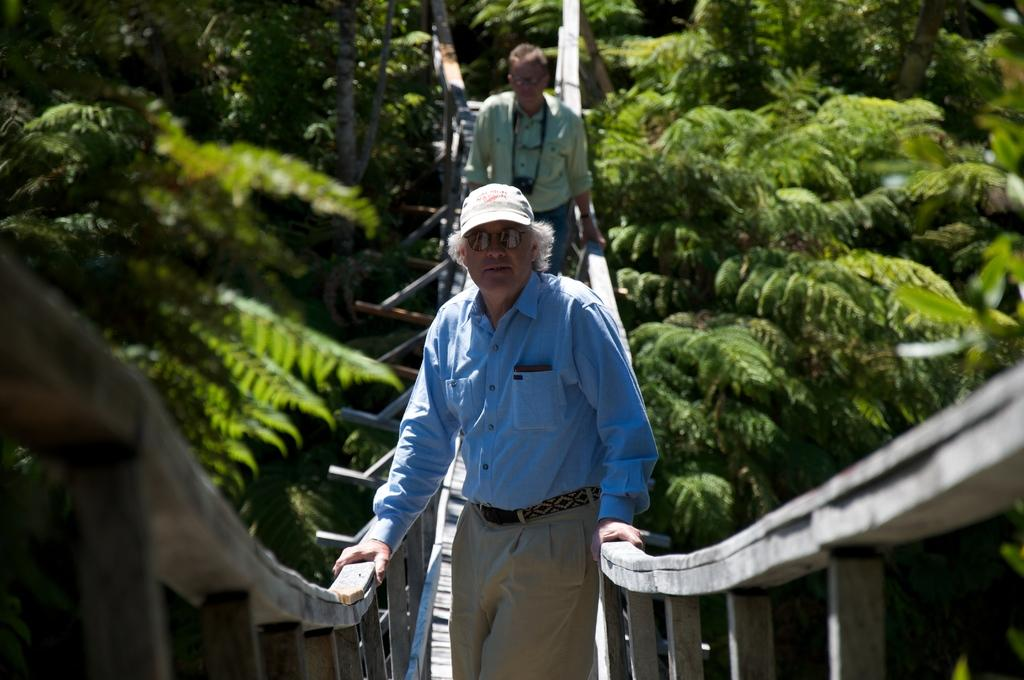How many people are in the image? There are two persons in the image. What are the persons standing on? The persons are standing on a wooden bridge. What type of vegetation can be seen in the image? There are trees in the image. What type of liquid is being poured from the bulb in the image? There is no bulb or liquid present in the image. 